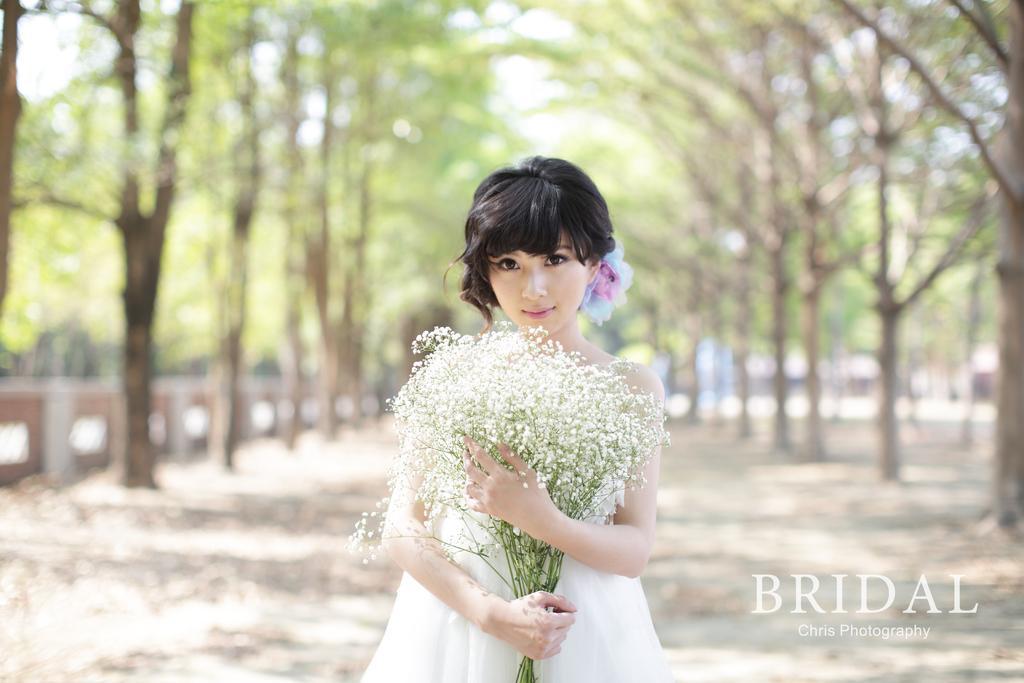Please provide a concise description of this image. A beautiful woman is standing by holding the flowers, she wore white color dress. There are trees on either side of this image, on the right side, there is a water mark 